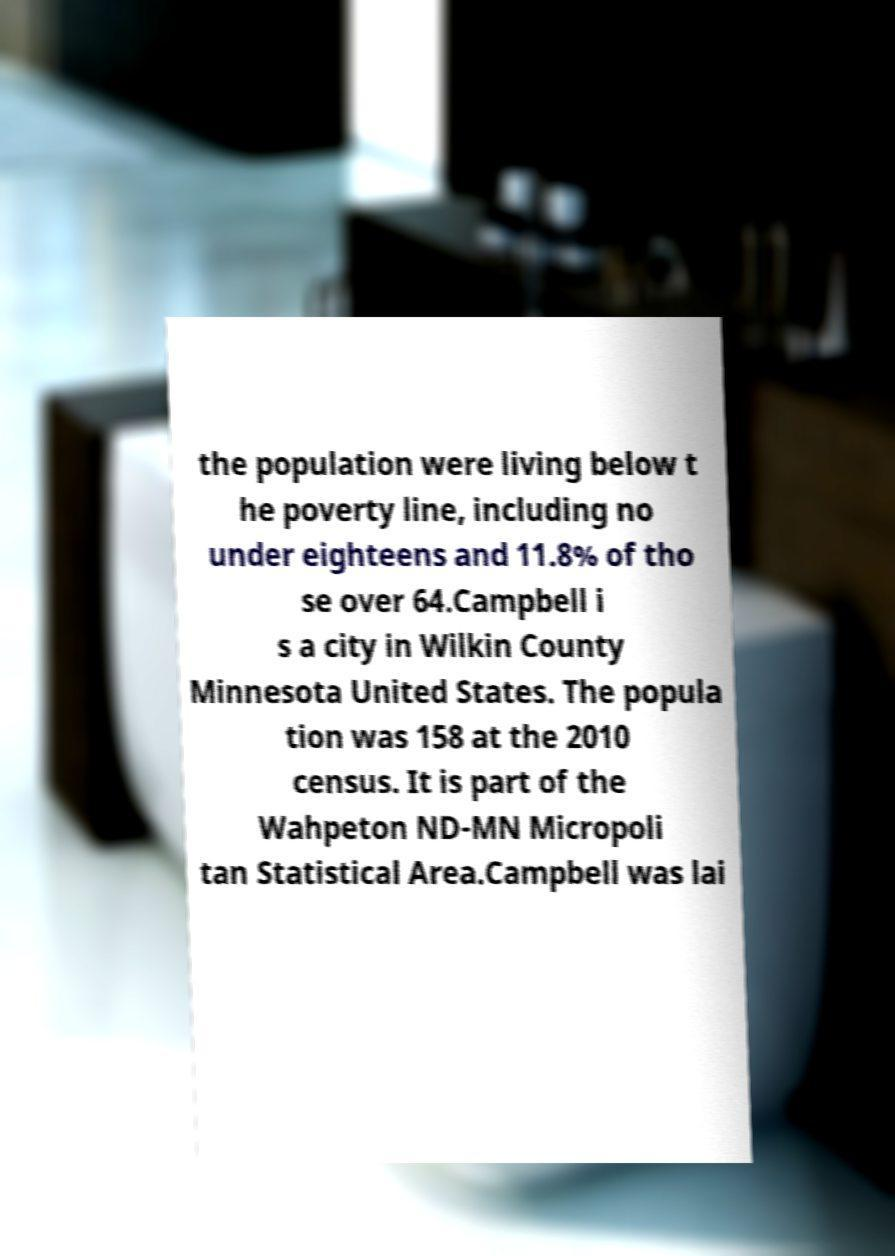Could you assist in decoding the text presented in this image and type it out clearly? the population were living below t he poverty line, including no under eighteens and 11.8% of tho se over 64.Campbell i s a city in Wilkin County Minnesota United States. The popula tion was 158 at the 2010 census. It is part of the Wahpeton ND-MN Micropoli tan Statistical Area.Campbell was lai 